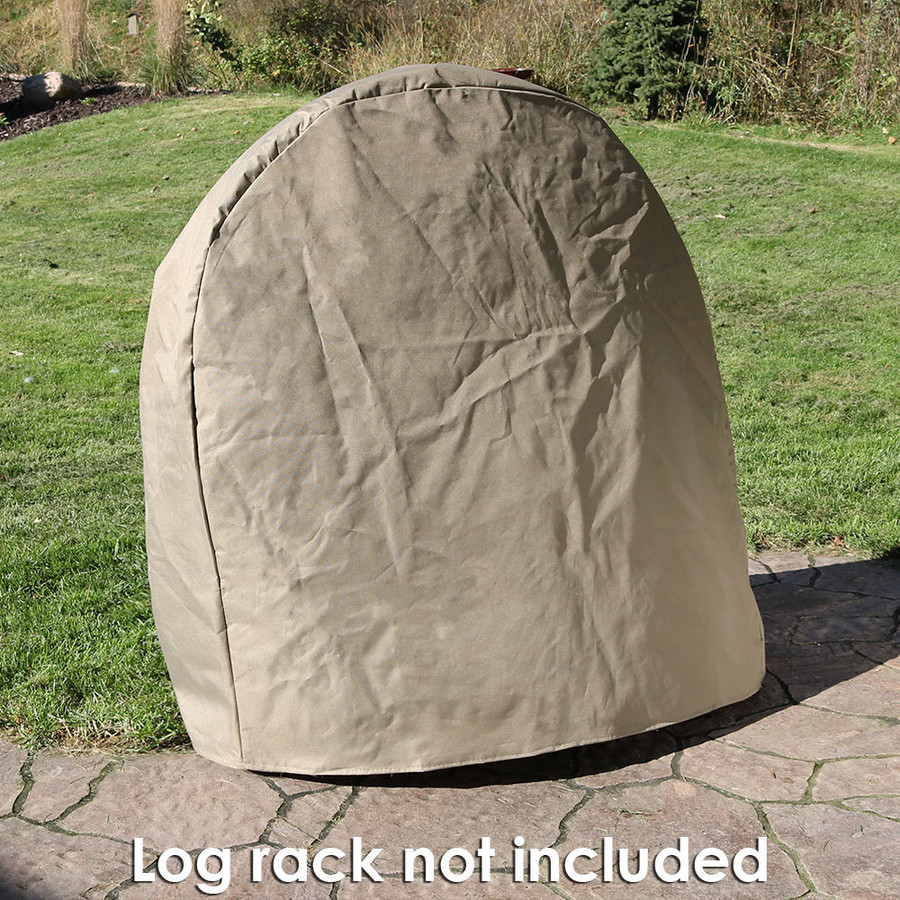What other objects can we observe in the background that might tell us more about the location? In the background, we can observe a natural, somewhat untamed shrubbery line and an open space that likely represents a larger yard or park area. There are no visible architectural structures close by, implying that this location might be more secluded or primarily used for relaxation or recreational purposes rather than dense residential or commercial use. 